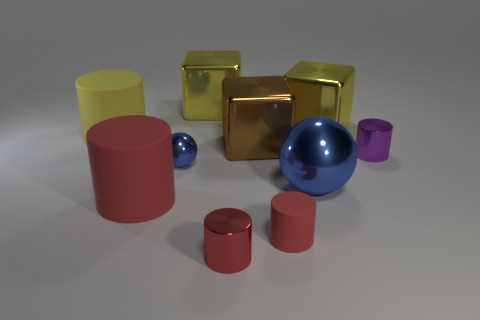Is there any other thing that is the same color as the small matte thing?
Your response must be concise. Yes. Are there any red rubber things that are to the left of the large matte thing that is in front of the large blue metal ball that is on the right side of the big red thing?
Your answer should be compact. No. There is a matte cylinder behind the purple thing; is it the same color as the small sphere?
Keep it short and to the point. No. What number of blocks are gray shiny things or large objects?
Your answer should be very brief. 3. What is the shape of the rubber object that is to the right of the large block on the left side of the brown object?
Ensure brevity in your answer.  Cylinder. What is the size of the blue ball to the left of the shiny object that is in front of the large matte object that is in front of the yellow matte object?
Provide a short and direct response. Small. Do the purple cylinder and the brown metallic cube have the same size?
Keep it short and to the point. No. How many things are either brown shiny blocks or small cylinders?
Keep it short and to the point. 4. There is a red rubber object on the left side of the small metal thing in front of the small rubber object; what is its size?
Your answer should be compact. Large. The yellow matte object is what size?
Keep it short and to the point. Large. 